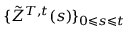<formula> <loc_0><loc_0><loc_500><loc_500>\{ \tilde { Z } ^ { T , t } ( s ) \} _ { 0 \leqslant s \leqslant t }</formula> 